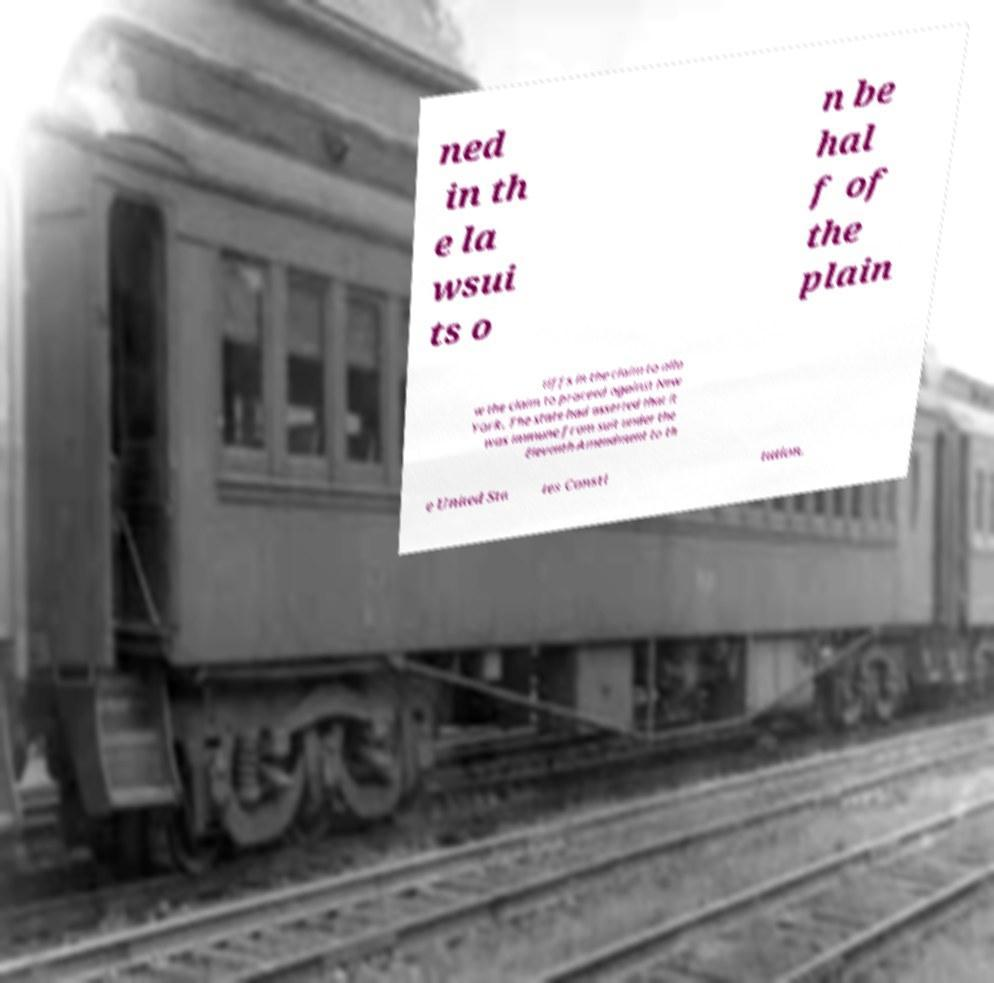For documentation purposes, I need the text within this image transcribed. Could you provide that? ned in th e la wsui ts o n be hal f of the plain tiffs in the claim to allo w the claim to proceed against New York. The state had asserted that it was immune from suit under the Eleventh Amendment to th e United Sta tes Consti tution. 